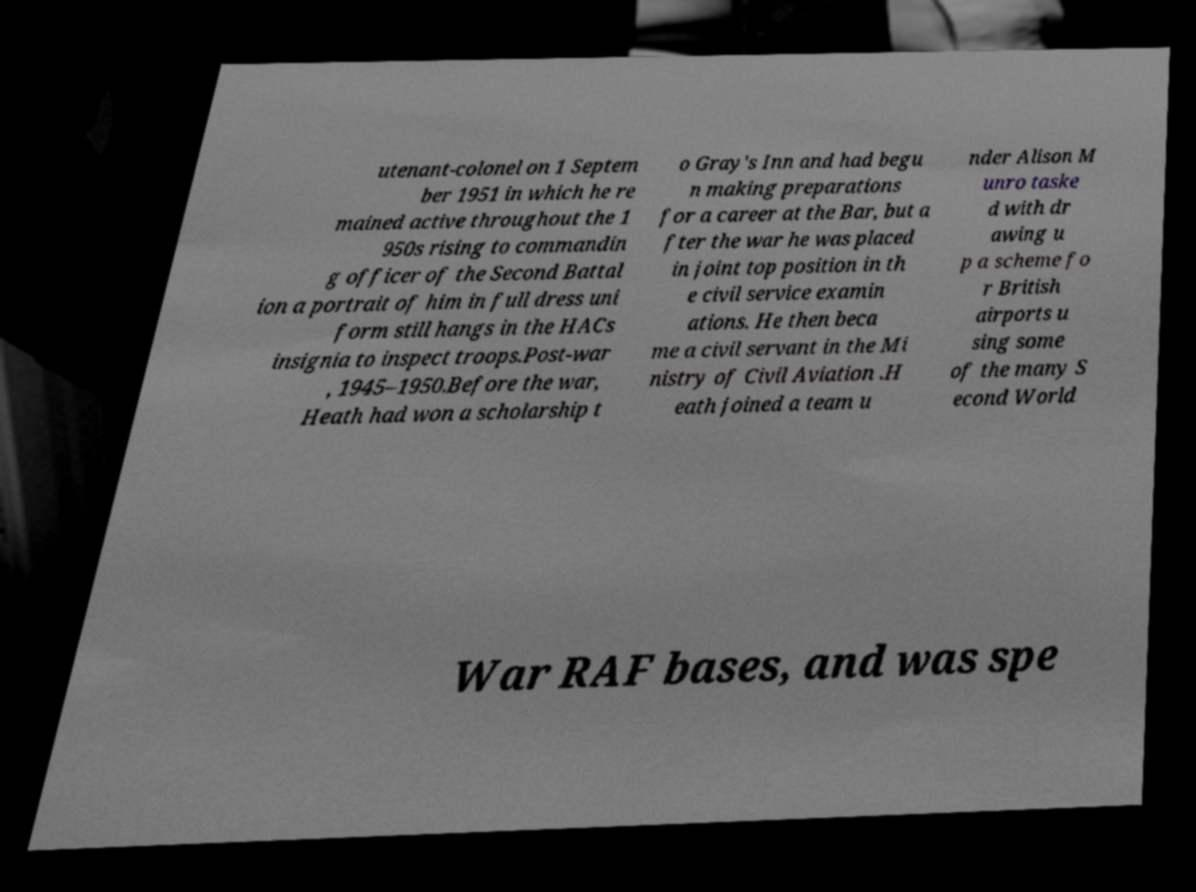For documentation purposes, I need the text within this image transcribed. Could you provide that? utenant-colonel on 1 Septem ber 1951 in which he re mained active throughout the 1 950s rising to commandin g officer of the Second Battal ion a portrait of him in full dress uni form still hangs in the HACs insignia to inspect troops.Post-war , 1945–1950.Before the war, Heath had won a scholarship t o Gray's Inn and had begu n making preparations for a career at the Bar, but a fter the war he was placed in joint top position in th e civil service examin ations. He then beca me a civil servant in the Mi nistry of Civil Aviation .H eath joined a team u nder Alison M unro taske d with dr awing u p a scheme fo r British airports u sing some of the many S econd World War RAF bases, and was spe 